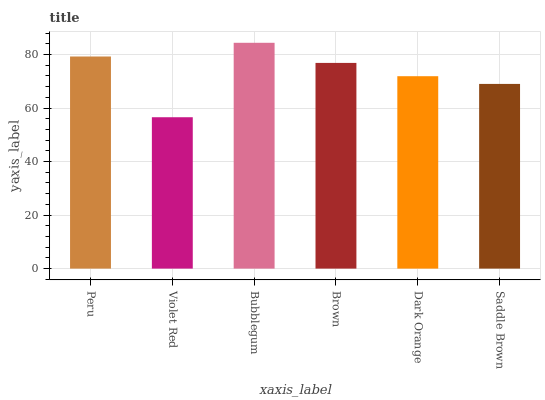Is Violet Red the minimum?
Answer yes or no. Yes. Is Bubblegum the maximum?
Answer yes or no. Yes. Is Bubblegum the minimum?
Answer yes or no. No. Is Violet Red the maximum?
Answer yes or no. No. Is Bubblegum greater than Violet Red?
Answer yes or no. Yes. Is Violet Red less than Bubblegum?
Answer yes or no. Yes. Is Violet Red greater than Bubblegum?
Answer yes or no. No. Is Bubblegum less than Violet Red?
Answer yes or no. No. Is Brown the high median?
Answer yes or no. Yes. Is Dark Orange the low median?
Answer yes or no. Yes. Is Dark Orange the high median?
Answer yes or no. No. Is Violet Red the low median?
Answer yes or no. No. 